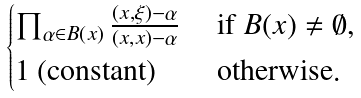Convert formula to latex. <formula><loc_0><loc_0><loc_500><loc_500>\begin{cases} \prod _ { \alpha \in B ( x ) } \frac { ( x , \xi ) - \alpha } { ( x , x ) - \alpha } & \text { if $B(x) \ne \emptyset$} , \\ 1 \text { (constant)} & \text { otherwise} . \end{cases}</formula> 